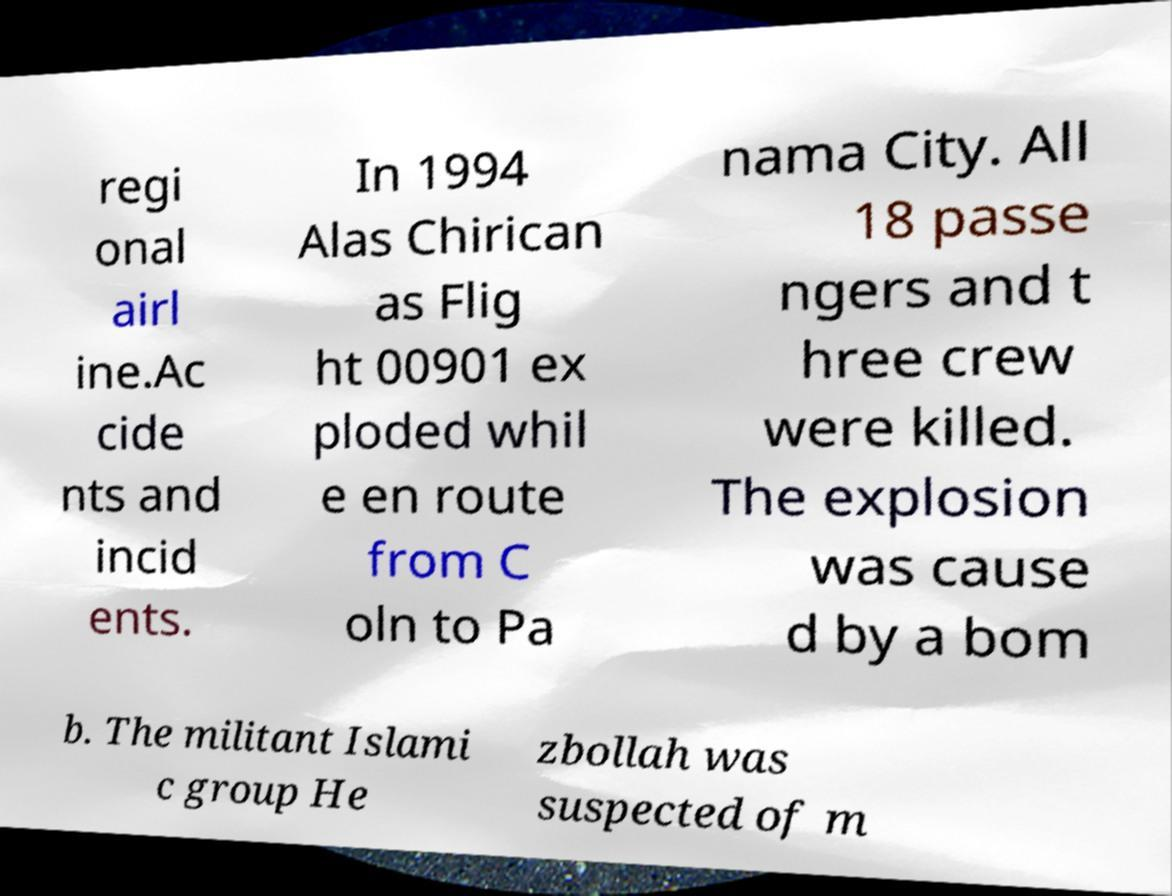Can you read and provide the text displayed in the image?This photo seems to have some interesting text. Can you extract and type it out for me? regi onal airl ine.Ac cide nts and incid ents. In 1994 Alas Chirican as Flig ht 00901 ex ploded whil e en route from C oln to Pa nama City. All 18 passe ngers and t hree crew were killed. The explosion was cause d by a bom b. The militant Islami c group He zbollah was suspected of m 